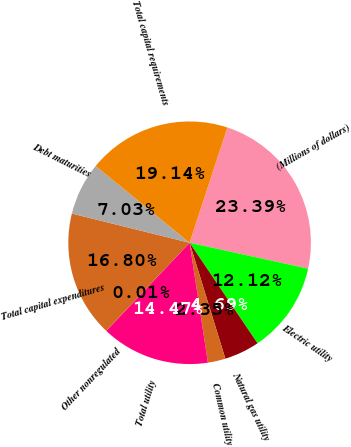<chart> <loc_0><loc_0><loc_500><loc_500><pie_chart><fcel>(Millions of dollars)<fcel>Electric utility<fcel>Natural gas utility<fcel>Common utility<fcel>Total utility<fcel>Other nonregulated<fcel>Total capital expenditures<fcel>Debt maturities<fcel>Total capital requirements<nl><fcel>23.39%<fcel>12.12%<fcel>4.69%<fcel>2.35%<fcel>14.47%<fcel>0.01%<fcel>16.8%<fcel>7.03%<fcel>19.14%<nl></chart> 